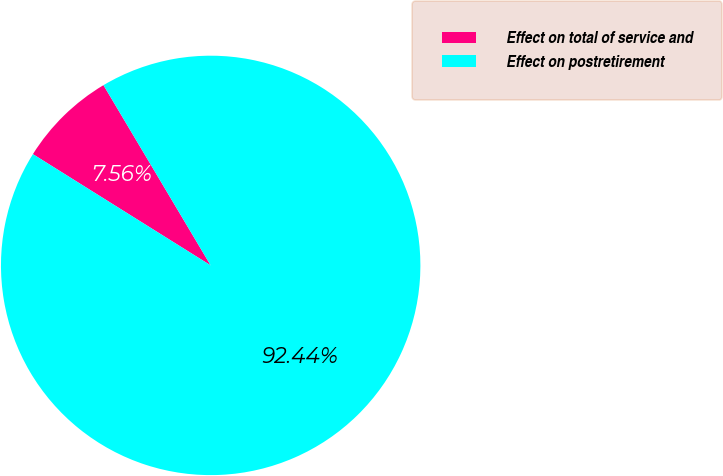<chart> <loc_0><loc_0><loc_500><loc_500><pie_chart><fcel>Effect on total of service and<fcel>Effect on postretirement<nl><fcel>7.56%<fcel>92.44%<nl></chart> 